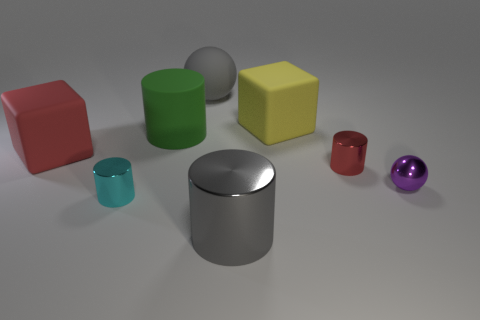What shape is the red thing that is made of the same material as the yellow object?
Your answer should be very brief. Cube. Is the size of the cyan metal object the same as the green rubber thing?
Keep it short and to the point. No. There is a cube that is left of the large cylinder behind the big red rubber cube; how big is it?
Make the answer very short. Large. There is a big thing that is the same color as the big shiny cylinder; what shape is it?
Offer a very short reply. Sphere. How many cylinders are purple things or big green objects?
Make the answer very short. 1. Does the gray cylinder have the same size as the red object that is to the left of the yellow object?
Your response must be concise. Yes. Are there more tiny purple things to the left of the tiny cyan cylinder than matte things?
Your answer should be very brief. No. There is a red object that is made of the same material as the big gray cylinder; what size is it?
Make the answer very short. Small. Is there a large rubber sphere that has the same color as the small metal ball?
Ensure brevity in your answer.  No. How many objects are either large metallic things or objects on the left side of the tiny purple metal sphere?
Offer a very short reply. 7. 